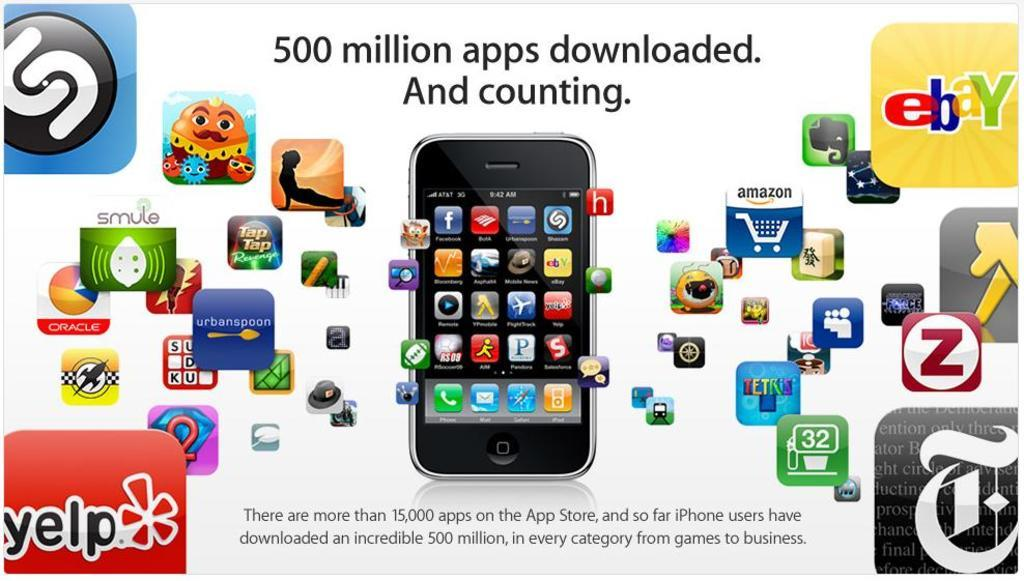<image>
Write a terse but informative summary of the picture. The phone shown has over 500 million apps. 